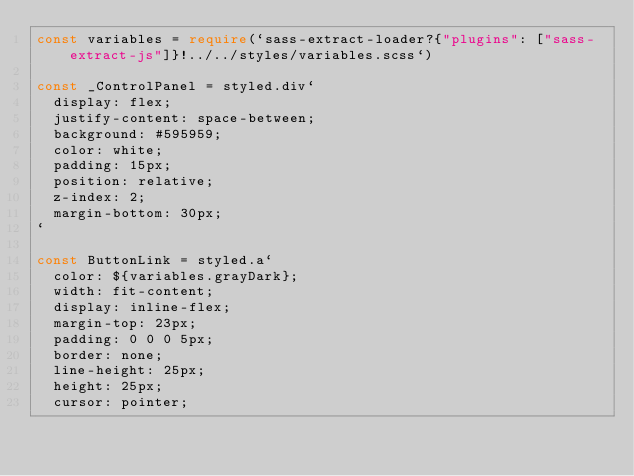Convert code to text. <code><loc_0><loc_0><loc_500><loc_500><_TypeScript_>const variables = require(`sass-extract-loader?{"plugins": ["sass-extract-js"]}!../../styles/variables.scss`)

const _ControlPanel = styled.div`
  display: flex;
  justify-content: space-between;
  background: #595959;
  color: white;
  padding: 15px;
  position: relative;
  z-index: 2;
  margin-bottom: 30px;
`

const ButtonLink = styled.a`
  color: ${variables.grayDark};
  width: fit-content;
  display: inline-flex;
  margin-top: 23px;
  padding: 0 0 0 5px;
  border: none;
  line-height: 25px;
  height: 25px;
  cursor: pointer;</code> 